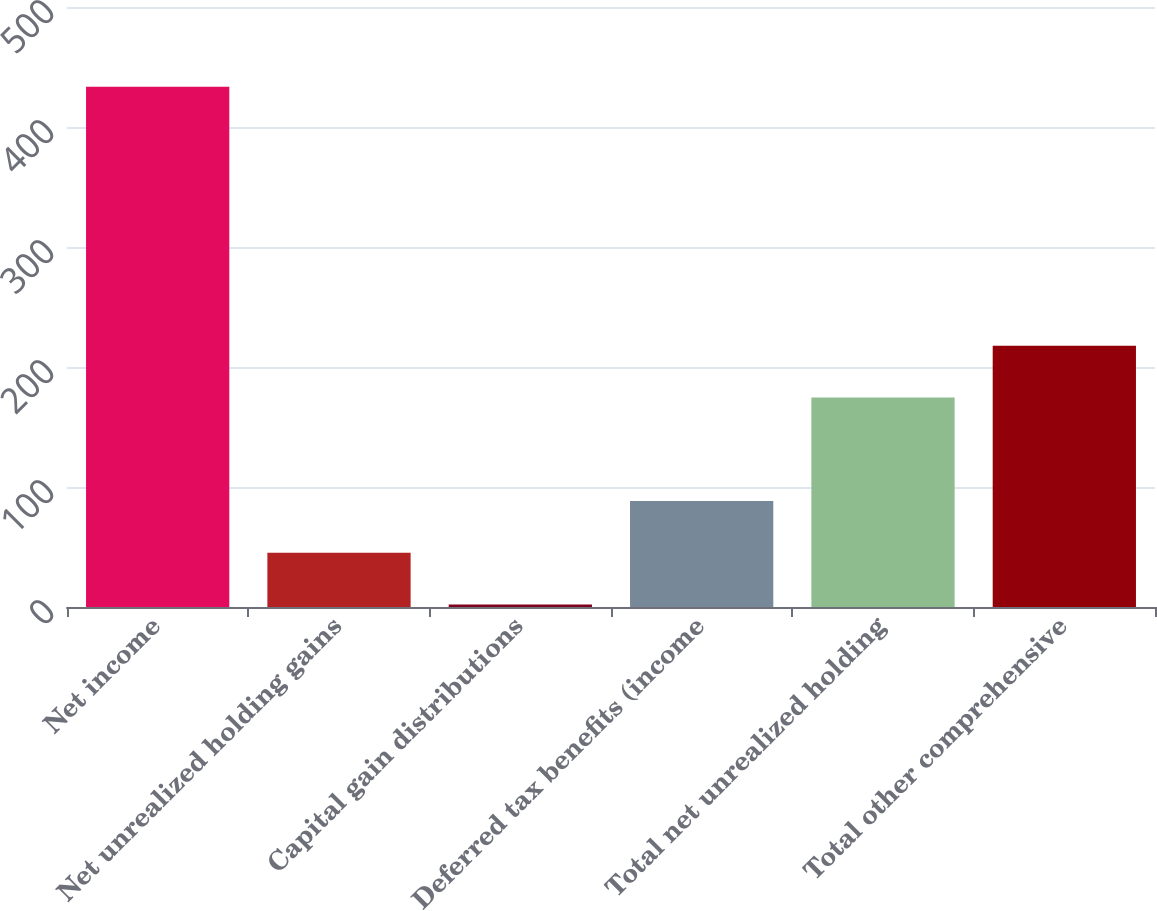Convert chart. <chart><loc_0><loc_0><loc_500><loc_500><bar_chart><fcel>Net income<fcel>Net unrealized holding gains<fcel>Capital gain distributions<fcel>Deferred tax benefits (income<fcel>Total net unrealized holding<fcel>Total other comprehensive<nl><fcel>433.6<fcel>45.16<fcel>2<fcel>88.32<fcel>174.64<fcel>217.8<nl></chart> 